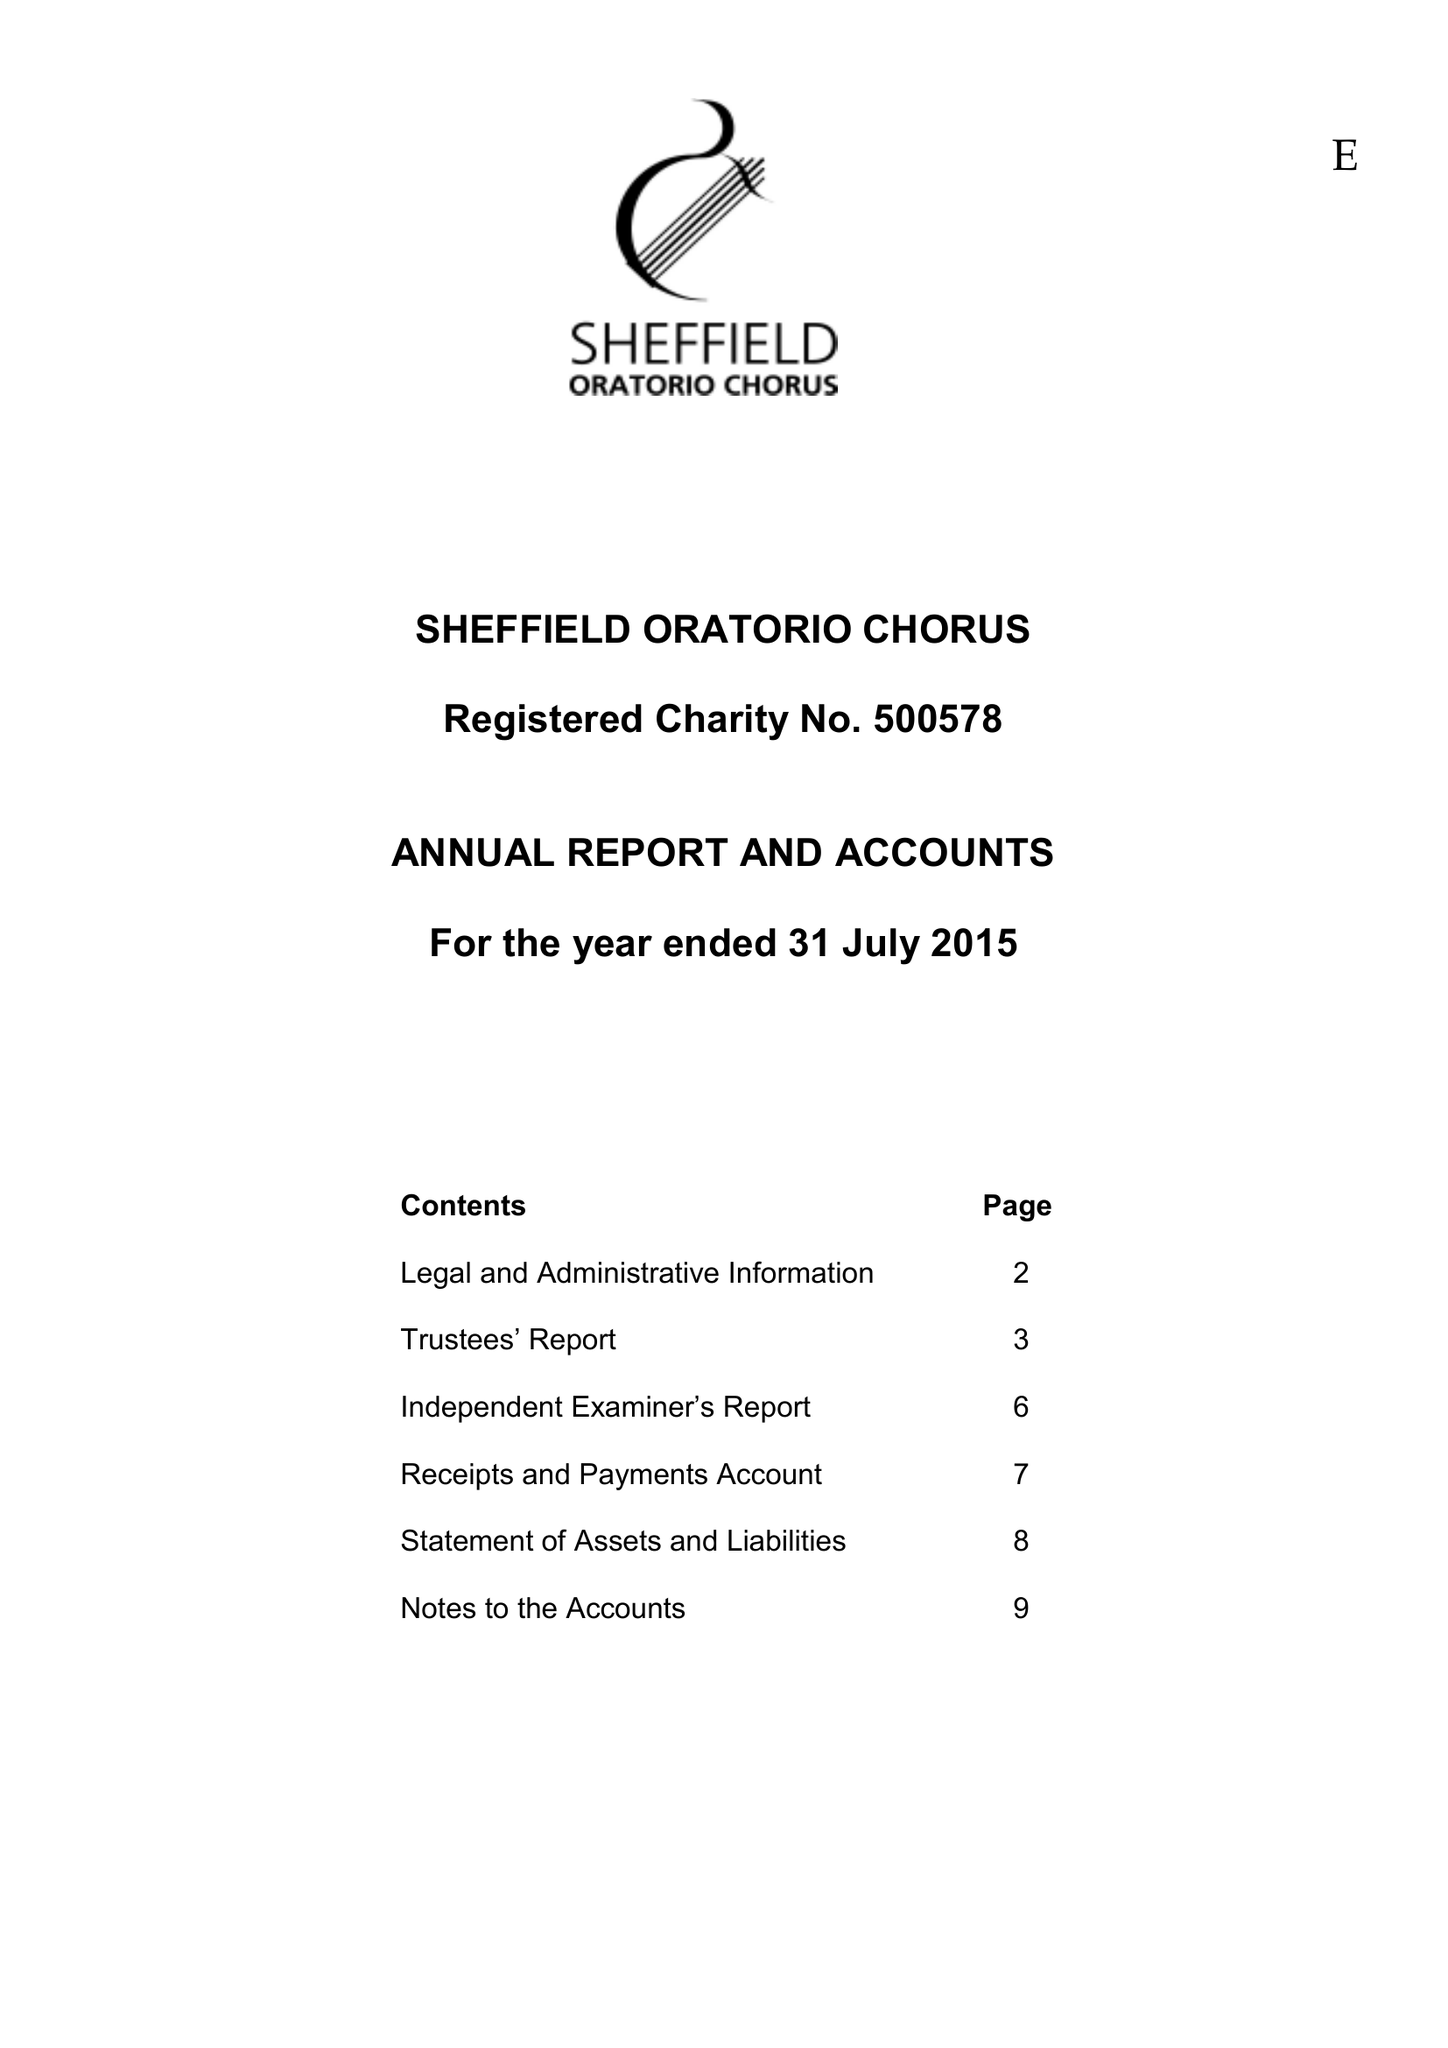What is the value for the address__street_line?
Answer the question using a single word or phrase. None 